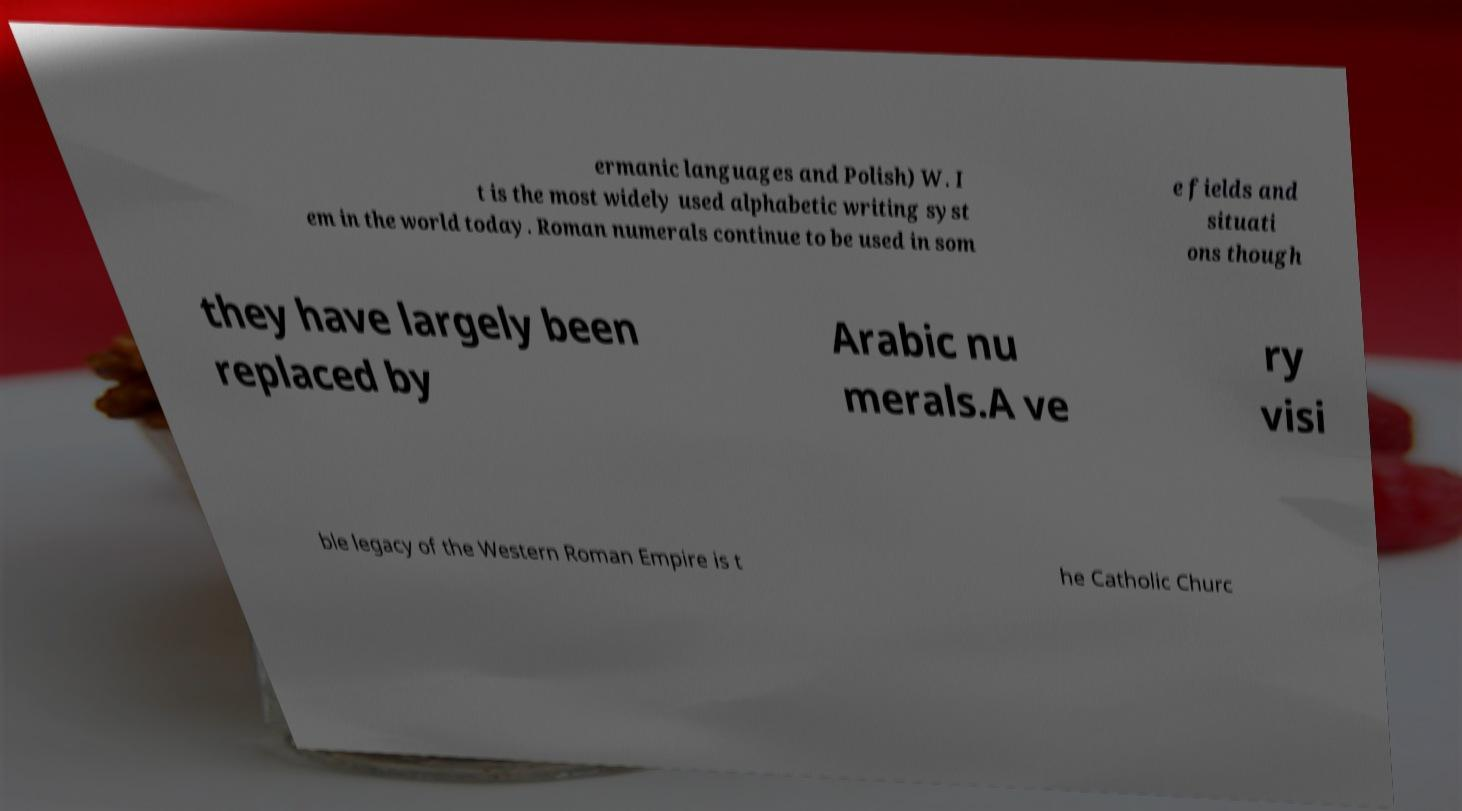For documentation purposes, I need the text within this image transcribed. Could you provide that? ermanic languages and Polish) W. I t is the most widely used alphabetic writing syst em in the world today. Roman numerals continue to be used in som e fields and situati ons though they have largely been replaced by Arabic nu merals.A ve ry visi ble legacy of the Western Roman Empire is t he Catholic Churc 